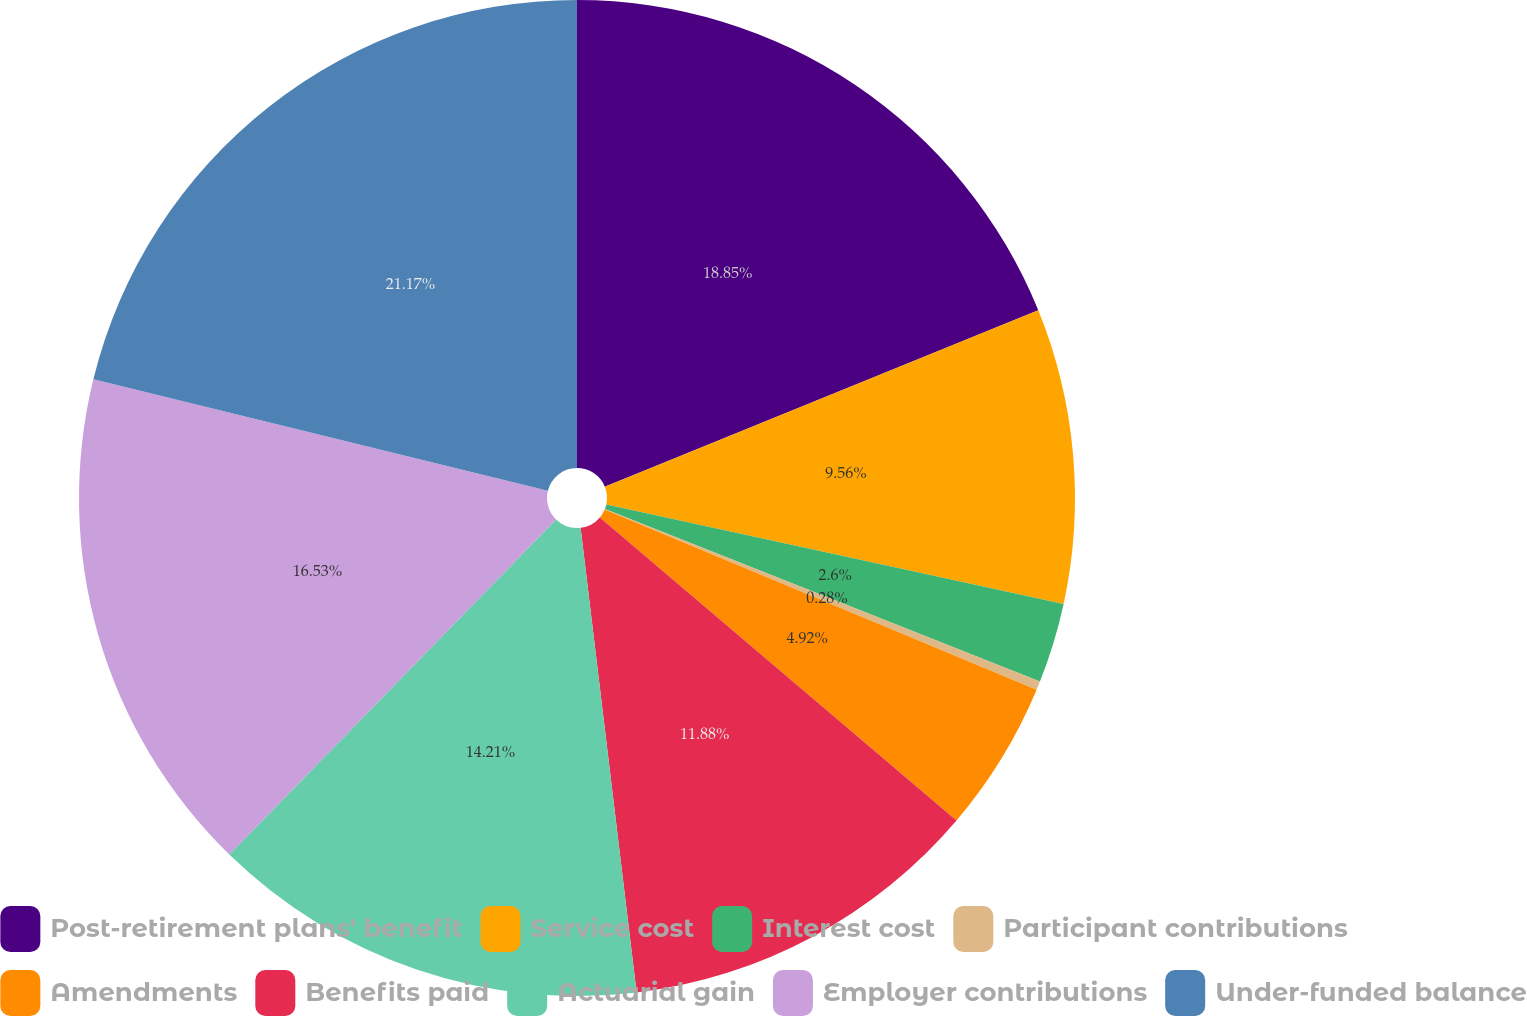Convert chart. <chart><loc_0><loc_0><loc_500><loc_500><pie_chart><fcel>Post-retirement plans' benefit<fcel>Service cost<fcel>Interest cost<fcel>Participant contributions<fcel>Amendments<fcel>Benefits paid<fcel>Actuarial gain<fcel>Employer contributions<fcel>Under-funded balance<nl><fcel>18.85%<fcel>9.56%<fcel>2.6%<fcel>0.28%<fcel>4.92%<fcel>11.88%<fcel>14.21%<fcel>16.53%<fcel>21.17%<nl></chart> 